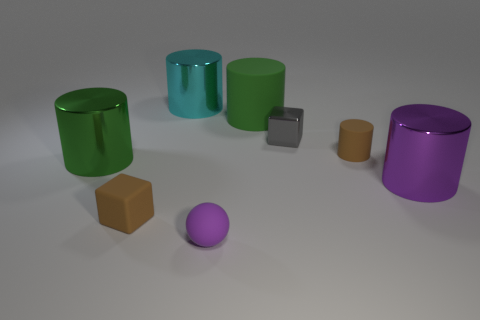Are there any reflections or textures in the image that provide information about the materials of the objects? Yes, the image shows a range of textures and reflections on the objects. The green and purple cylinders have glossy surfaces which reflect the light, indicating they are likely made of a reflective material such as plastic or polished metal. The small grey and brown cubes have matte textures that don't reflect light, suggesting a possible material like stone, clay, or unpolished wood or plastic. The varying textures and reflections offer insight into the possible composition of each object. 